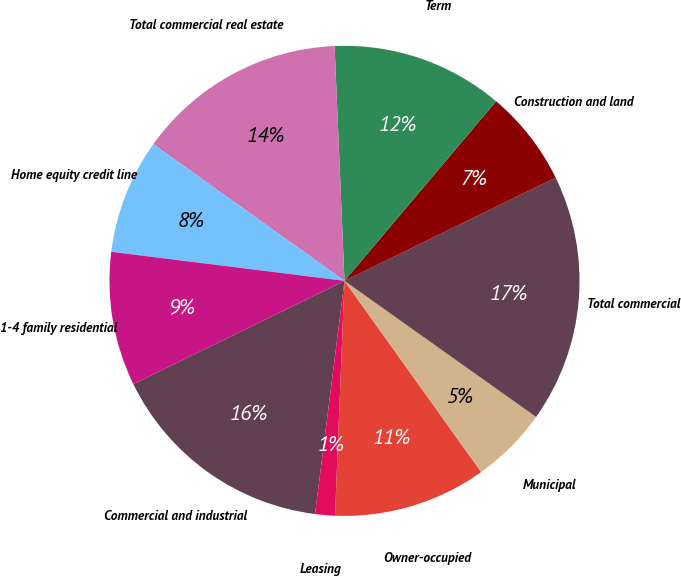<chart> <loc_0><loc_0><loc_500><loc_500><pie_chart><fcel>Commercial and industrial<fcel>Leasing<fcel>Owner-occupied<fcel>Municipal<fcel>Total commercial<fcel>Construction and land<fcel>Term<fcel>Total commercial real estate<fcel>Home equity credit line<fcel>1-4 family residential<nl><fcel>15.76%<fcel>1.36%<fcel>10.52%<fcel>5.29%<fcel>17.07%<fcel>6.6%<fcel>11.83%<fcel>14.45%<fcel>7.91%<fcel>9.21%<nl></chart> 